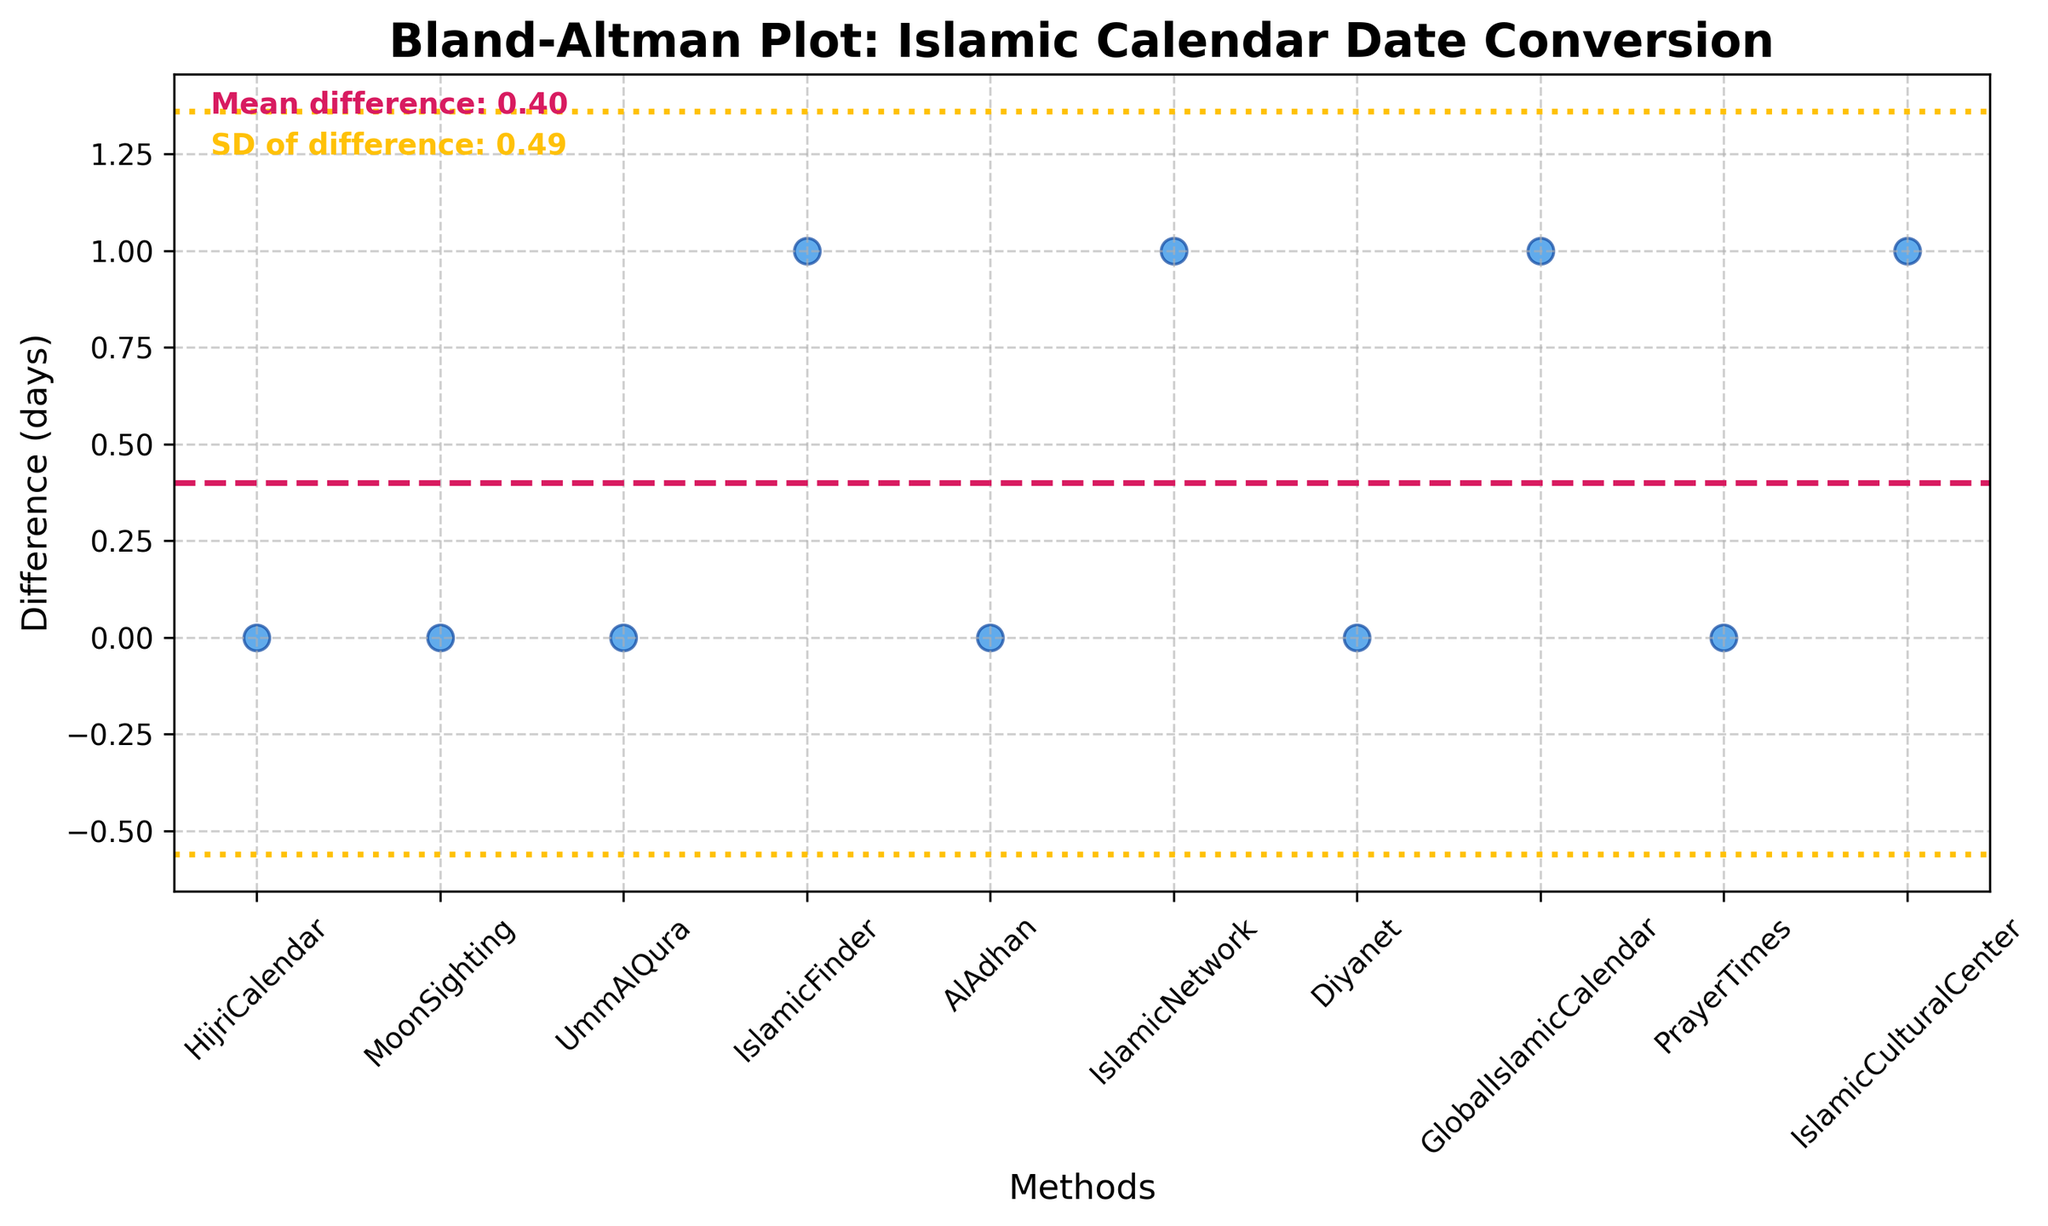How many methods are compared in the plot? The plot displays data points for each method along the x-axis, allowing us to count the number of unique methods compared.
Answer: 10 What is the mean difference observed in the plot? The mean difference is marked by a horizontal line, and its value is also written as a text annotation on the plot.
Answer: 0.4 What are the upper and lower limits of agreement? The limits of agreement are visually represented by the dotted lines and their values can be found using the formula for the limits: mean difference ± 1.96 * standard deviation of difference. These values are also likely annotated on the plot.
Answer: Upper Limit: 1.6, Lower Limit: -0.8 Which method shows the largest deviation in date conversion? By examining the individual data points, we identify the method with the highest vertical distance from the mean difference line, indicating the largest deviation.
Answer: IslamicFinder, IslamicNetwork, GlobalIslamicCalendar, and IslamicCulturalCenter (all have a deviation of 1) How many methods show no difference in date conversion? Count the number of points that fall directly on the 0 mark on the y-axis, which indicates no difference in date conversion.
Answer: 6 methods What is the standard deviation of the differences? The standard deviation is visually annotated on the plot and could also be inferred from the spread of the data points around the mean difference line.
Answer: 0.49 How does the mean difference compare to the standard deviation of the differences? The mean difference and the standard deviation values are annotated on the plot, and their comparison involves examining their relative magnitudes.
Answer: The mean difference (0.4) is less than the standard deviation (0.49) Which methods have a positive difference in date conversion? Look for data points above the 0 mark on the y-axis, which indicates a positive difference in date conversion.
Answer: IslamicFinder, IslamicNetwork, GlobalIslamicCalendar, and IslamicCulturalCenter How many methods are closer to the mean difference line than to the limits of agreement? Count the number of points that lie within the range defined by the mean difference ± 1.96 * standard deviation.
Answer: All methods (10 methods) What is the impact of using different methods on date conversion accuracy as depicted in the plot? By examining how close most data points are to the mean difference line and understanding the spread (standard deviation), we can infer the accuracy and consistency of different methods. Most methods show no or minimal differences, with some showing a slight difference but within acceptable limits.
Answer: Generally accurate with slight deviations 